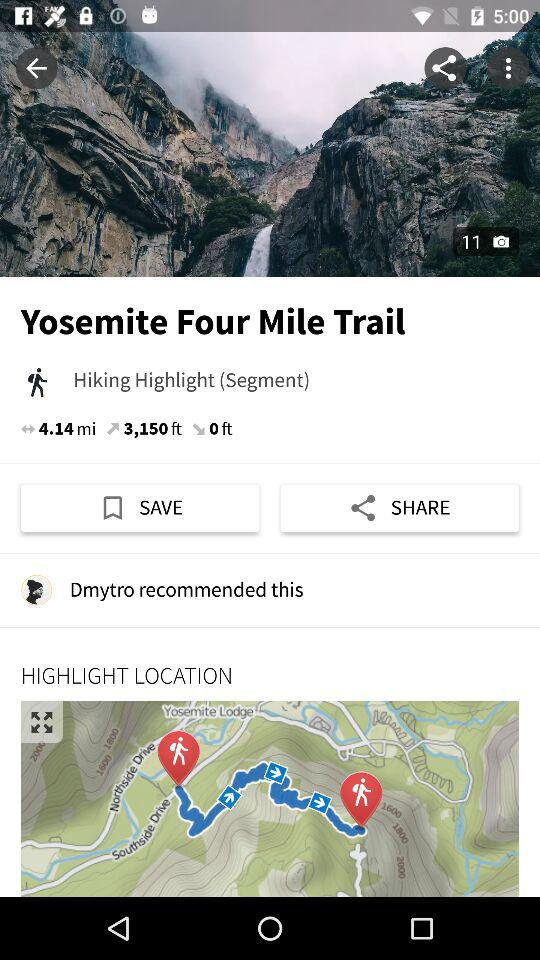How long is this hike?
Answer the question using a single word or phrase. 4.14 miles 